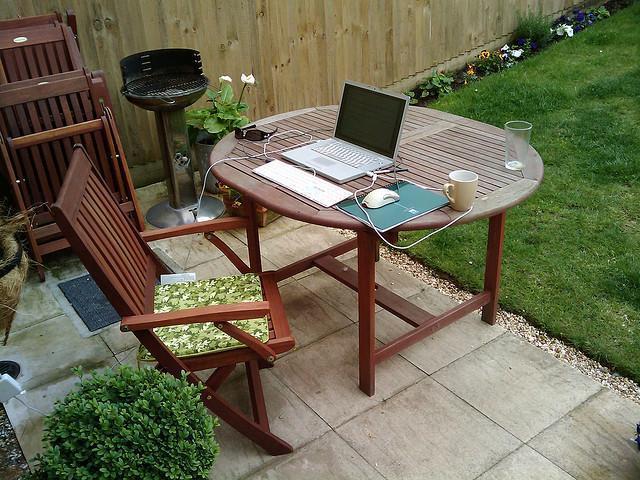How many people can sit at the table?
Give a very brief answer. 1. How many chairs can be seen?
Give a very brief answer. 3. How many potted plants can be seen?
Give a very brief answer. 2. 